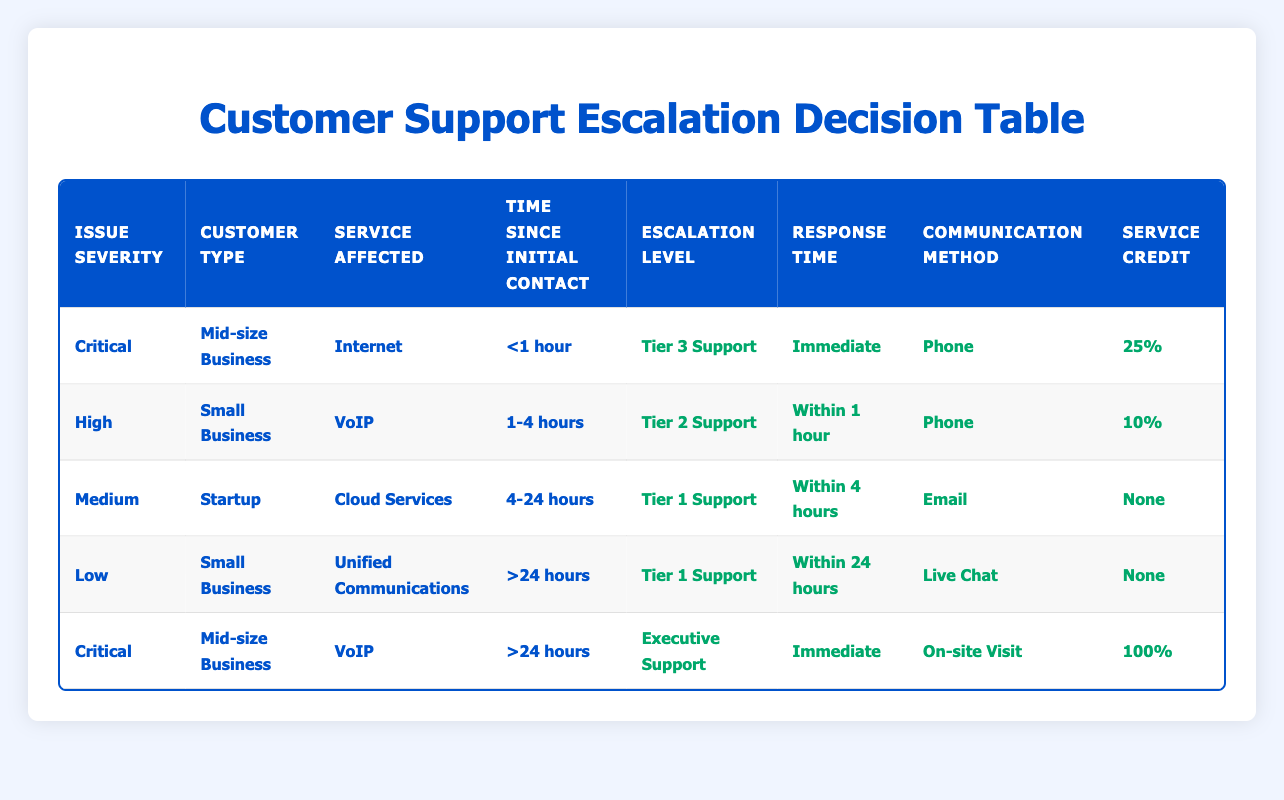What escalation level is assigned to a medium-severity issue for a startup? From the table, a medium-severity issue for a startup is categorized under the conditions: Issue Severity as "Medium", Customer Type as "Startup". According to the corresponding row in the table, the escalation level for these conditions is "Tier 1 Support".
Answer: Tier 1 Support Is a service credit offered for critical issues with mid-size businesses? Looking at the table, there are two rows for critical issues involving mid-size businesses - one for Internet service (<1 hour) and one for VoIP service (>24 hours). The first row grants a 25% service credit, while the second row grants a 100% service credit. Therefore, service credits are indeed offered.
Answer: Yes What is the required response time for high-severity VoIP issues for small businesses? The specific row indicating high severity for small business with VoIP service states a response time of "Within 1 hour". Therefore, this is the required response time for such issues.
Answer: Within 1 hour For critical issues with a mid-size business, what communication method is employed if the time since initial contact is greater than 24 hours? In the case of critical issues with mid-size businesses when the time since initial contact is greater than 24 hours, the table shows that the communication method is "On-site Visit".
Answer: On-site Visit How many different escalation levels are mentioned in the table? By examining the actions across all rows, the escalation levels listed are Tier 1 Support, Tier 2 Support, Tier 3 Support, Account Manager, and Executive Support. Counting these gives a total of 5 different escalation levels.
Answer: 5 What is the difference in the service credits between critical issues handled immediately and those that are handled after more than 24 hours? For critical issues handled immediately (<1 hour), the service credit is 25%. For those handled after >24 hours, the credit is 100%. The difference is calculated as 100% - 25% = 75%.
Answer: 75% Does response time vary based on customer type for medium-severity issues? Reviewing the table, medium-severity issues for startups yield a response time of "Within 4 hours". However, no other customer types are listed for medium-severity issues, so there is no data to compare. Therefore, we cannot definitively say that response time varies.
Answer: No What is the service credit percentage for a low-severity issue with unified communications if the time since initial contact exceeds 24 hours? In the relevant row, the table shows that for a low-severity issue affecting unified communications with a time since initial contact of greater than 24 hours, the service credit is "None".
Answer: None 